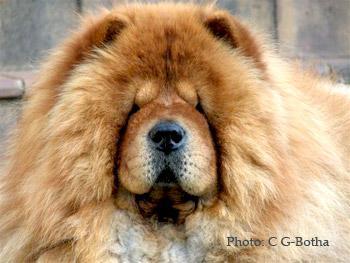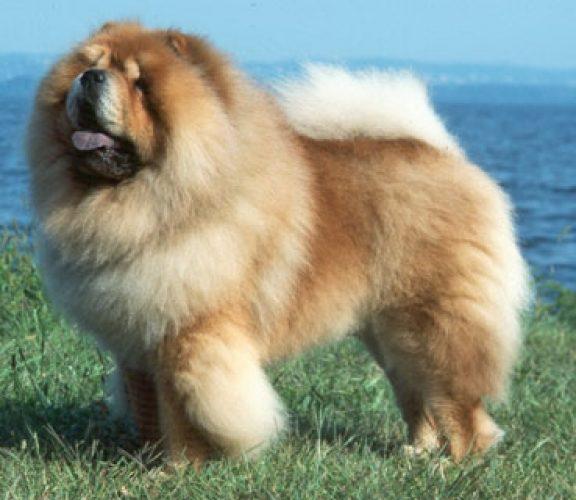The first image is the image on the left, the second image is the image on the right. Given the left and right images, does the statement "One of the images only shows the head of a dog." hold true? Answer yes or no. Yes. 